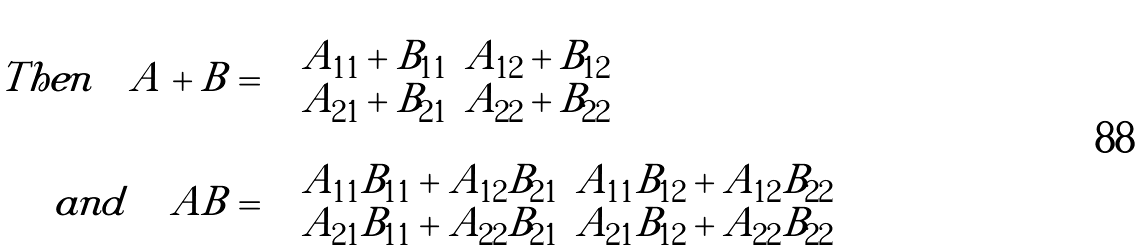Convert formula to latex. <formula><loc_0><loc_0><loc_500><loc_500>T h e n \quad A + B & = \left ( \begin{array} { c c } A _ { 1 1 } + B _ { 1 1 } & A _ { 1 2 } + B _ { 1 2 } \\ A _ { 2 1 } + B _ { 2 1 } & A _ { 2 2 } + B _ { 2 2 } \end{array} \right ) \\ \quad a n d \quad \, A B & = \left ( \begin{array} { c c } A _ { 1 1 } B _ { 1 1 } + A _ { 1 2 } B _ { 2 1 } & A _ { 1 1 } B _ { 1 2 } + A _ { 1 2 } B _ { 2 2 } \\ A _ { 2 1 } B _ { 1 1 } + A _ { 2 2 } B _ { 2 1 } & A _ { 2 1 } B _ { 1 2 } + A _ { 2 2 } B _ { 2 2 } \end{array} \right )</formula> 